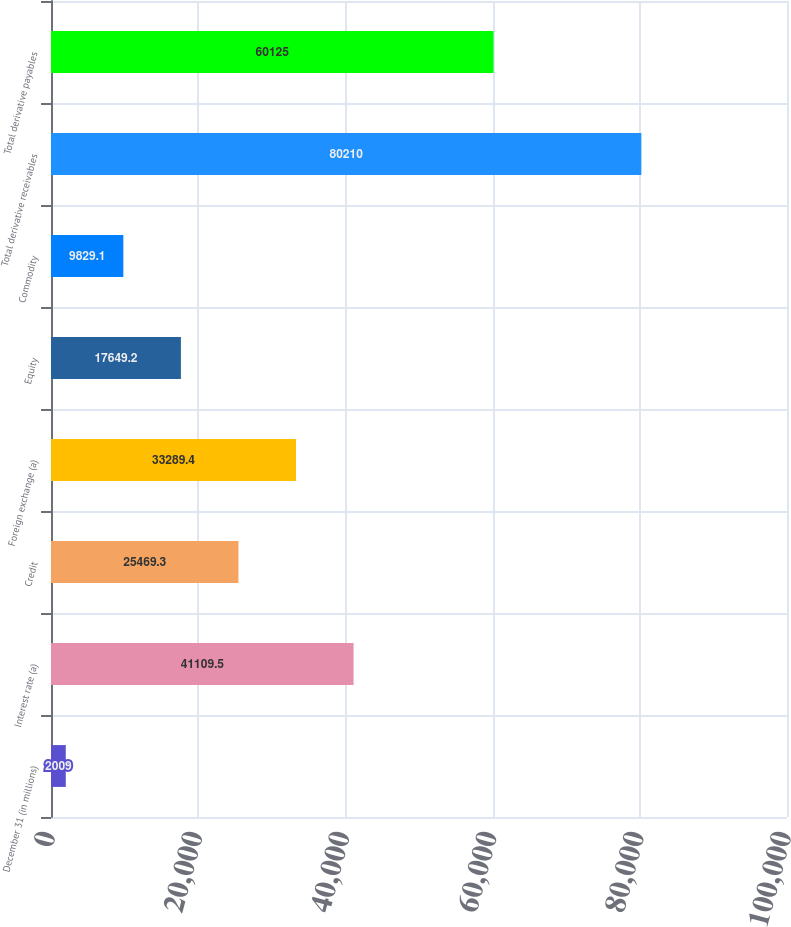Convert chart to OTSL. <chart><loc_0><loc_0><loc_500><loc_500><bar_chart><fcel>December 31 (in millions)<fcel>Interest rate (a)<fcel>Credit<fcel>Foreign exchange (a)<fcel>Equity<fcel>Commodity<fcel>Total derivative receivables<fcel>Total derivative payables<nl><fcel>2009<fcel>41109.5<fcel>25469.3<fcel>33289.4<fcel>17649.2<fcel>9829.1<fcel>80210<fcel>60125<nl></chart> 